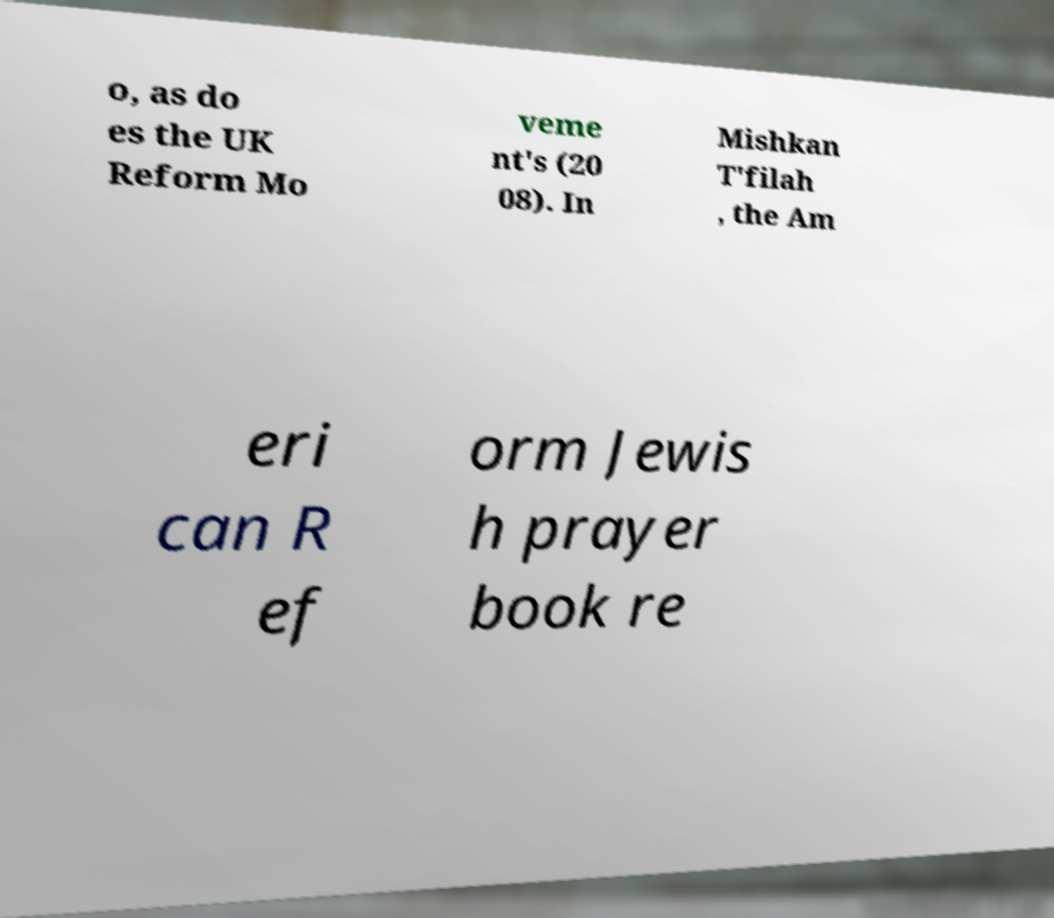There's text embedded in this image that I need extracted. Can you transcribe it verbatim? o, as do es the UK Reform Mo veme nt's (20 08). In Mishkan T'filah , the Am eri can R ef orm Jewis h prayer book re 